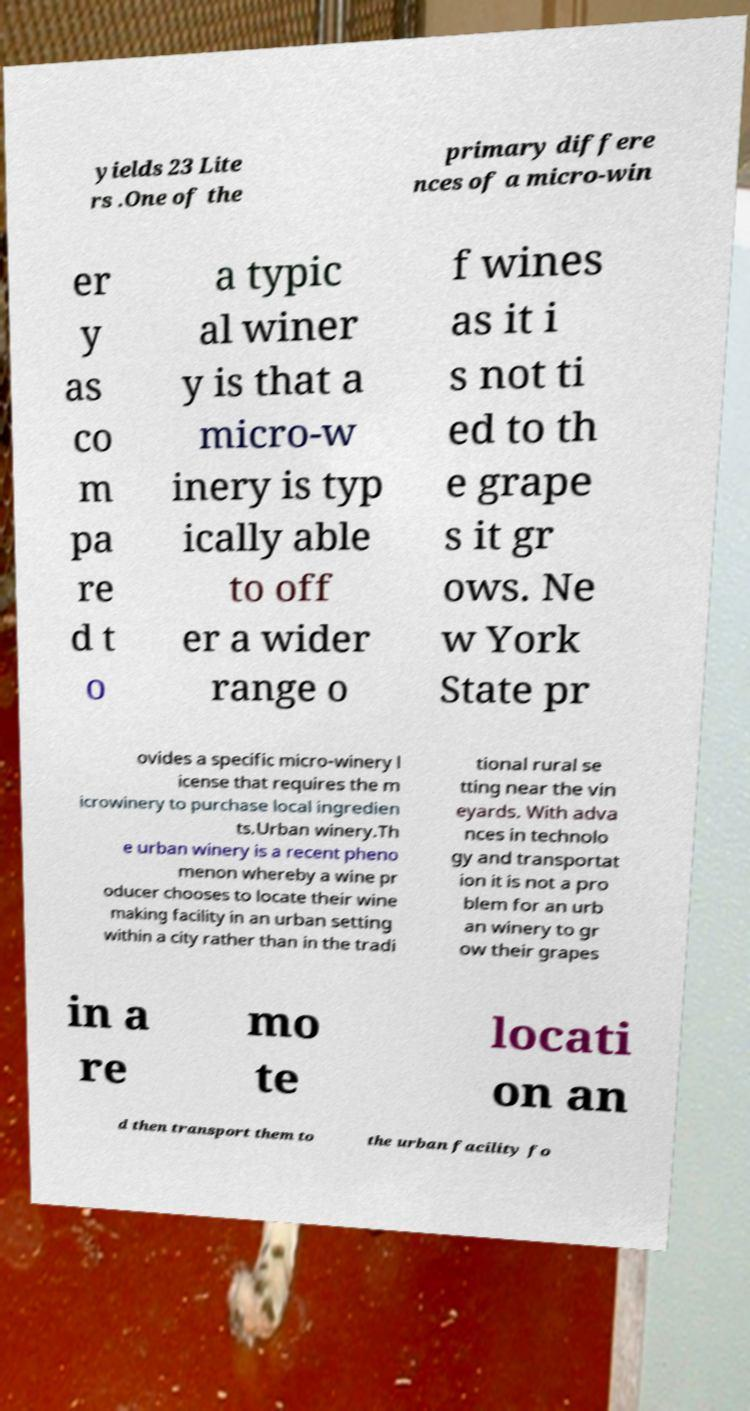I need the written content from this picture converted into text. Can you do that? yields 23 Lite rs .One of the primary differe nces of a micro-win er y as co m pa re d t o a typic al winer y is that a micro-w inery is typ ically able to off er a wider range o f wines as it i s not ti ed to th e grape s it gr ows. Ne w York State pr ovides a specific micro-winery l icense that requires the m icrowinery to purchase local ingredien ts.Urban winery.Th e urban winery is a recent pheno menon whereby a wine pr oducer chooses to locate their wine making facility in an urban setting within a city rather than in the tradi tional rural se tting near the vin eyards. With adva nces in technolo gy and transportat ion it is not a pro blem for an urb an winery to gr ow their grapes in a re mo te locati on an d then transport them to the urban facility fo 